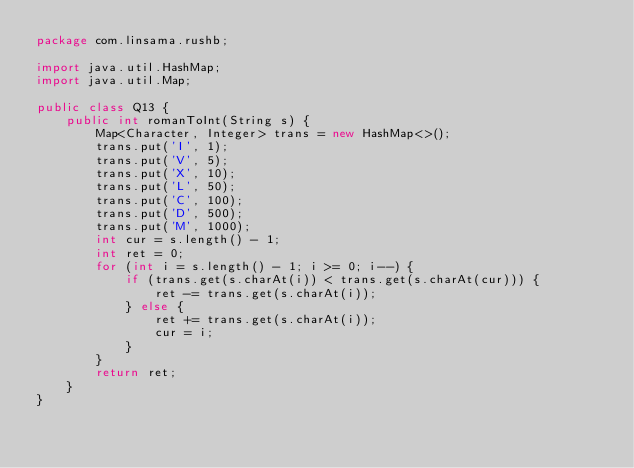<code> <loc_0><loc_0><loc_500><loc_500><_Java_>package com.linsama.rushb;

import java.util.HashMap;
import java.util.Map;

public class Q13 {
    public int romanToInt(String s) {
        Map<Character, Integer> trans = new HashMap<>();
        trans.put('I', 1);
        trans.put('V', 5);
        trans.put('X', 10);
        trans.put('L', 50);
        trans.put('C', 100);
        trans.put('D', 500);
        trans.put('M', 1000);
        int cur = s.length() - 1;
        int ret = 0;
        for (int i = s.length() - 1; i >= 0; i--) {
            if (trans.get(s.charAt(i)) < trans.get(s.charAt(cur))) {
                ret -= trans.get(s.charAt(i));
            } else {
                ret += trans.get(s.charAt(i));
                cur = i;
            }
        }
        return ret;
    }
}
</code> 